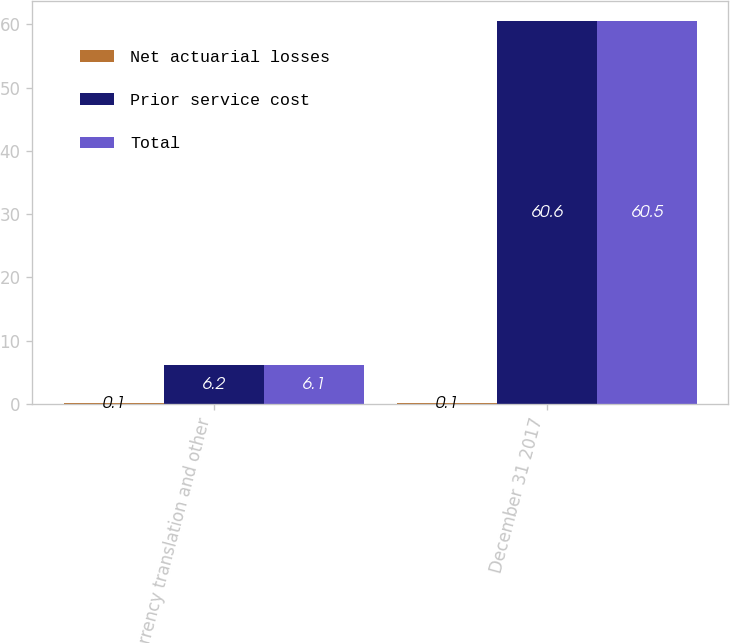<chart> <loc_0><loc_0><loc_500><loc_500><stacked_bar_chart><ecel><fcel>Currency translation and other<fcel>December 31 2017<nl><fcel>Net actuarial losses<fcel>0.1<fcel>0.1<nl><fcel>Prior service cost<fcel>6.2<fcel>60.6<nl><fcel>Total<fcel>6.1<fcel>60.5<nl></chart> 